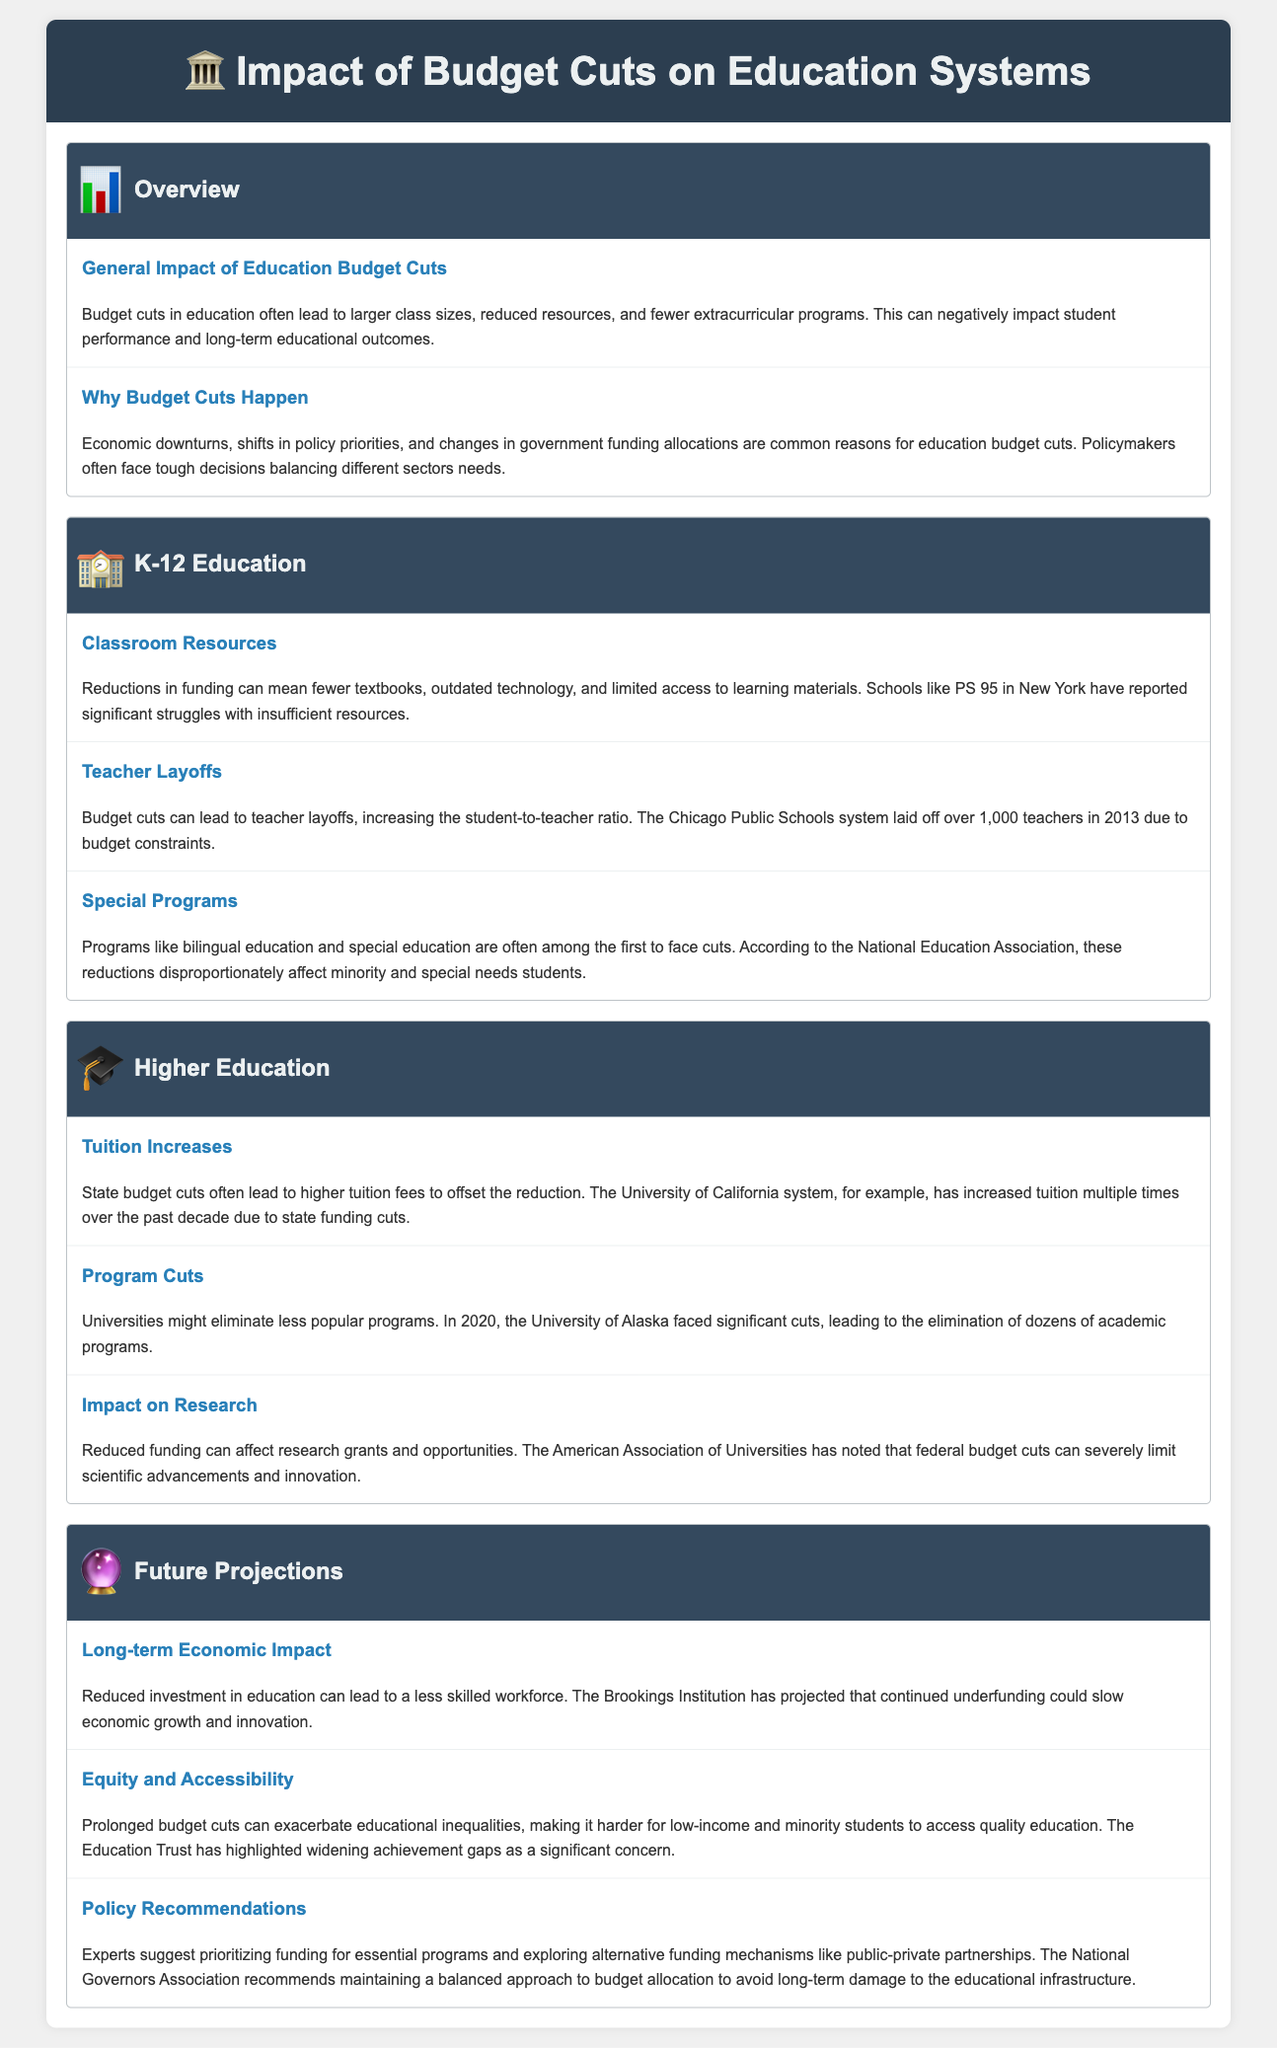What is the impact of budget cuts on classroom resources? Budget cuts can lead to fewer textbooks, outdated technology, and limited access to learning materials.
Answer: Fewer textbooks, outdated technology, and limited access to learning materials What is a common reason for education budget cuts? Common reasons include economic downturns, shifts in policy priorities, and changes in government funding allocations.
Answer: Economic downturns How many teachers did Chicago Public Schools lay off in 2013? The document states that Chicago Public Schools laid off over 1,000 teachers due to budget constraints.
Answer: Over 1,000 teachers What impact do budget cuts have on bilingual education programs? Budget cuts often lead to reductions in programs like bilingual education, disproportionately affecting minority students.
Answer: Reductions in programs What trend has been noted regarding tuition fees in higher education? State budget cuts often lead to higher tuition fees to offset the reduction in funding.
Answer: Higher tuition fees What program cuts did the University of Alaska face in 2020? The University of Alaska eliminated dozens of academic programs due to significant cuts in funding.
Answer: Dozens of academic programs What long-term economic impact could reduced investment in education have? Continued underfunding could slow economic growth and innovation, as projected by the Brookings Institution.
Answer: Slow economic growth What is one recommendation by experts to address budget cuts? Experts suggest prioritizing funding for essential programs and exploring alternative funding mechanisms.
Answer: Prioritizing funding for essential programs 